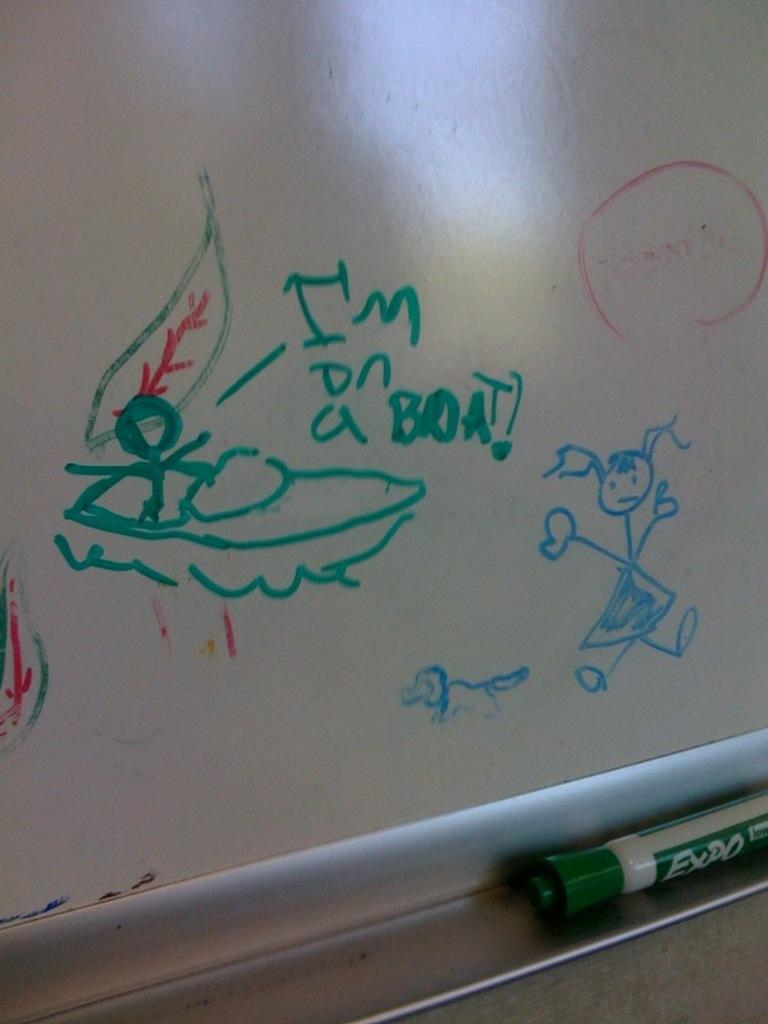<image>
Describe the image concisely. A white board has a picture of a boat and I'm on a boat in green. 